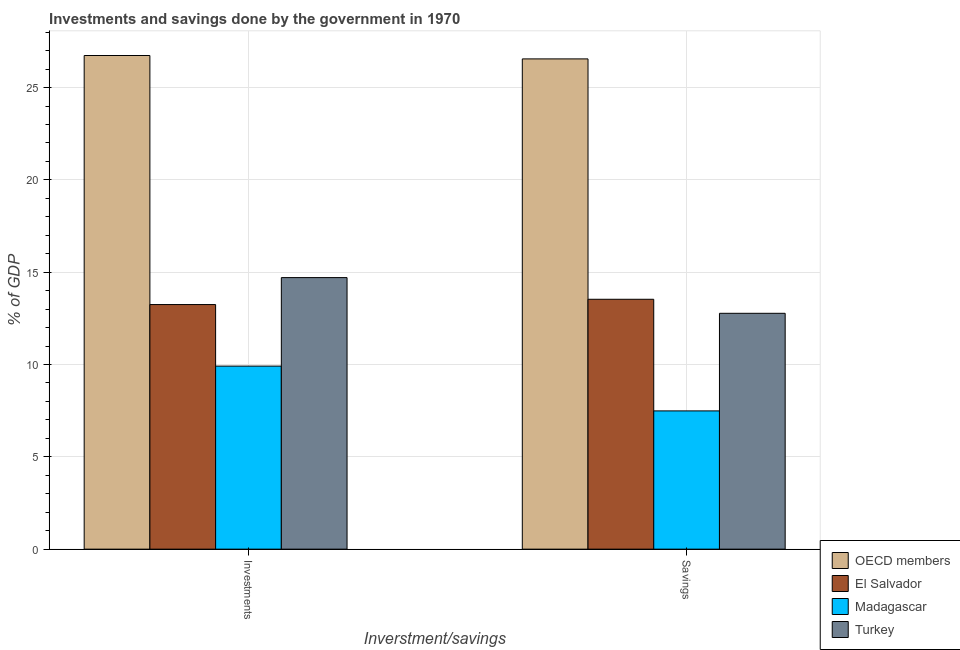Are the number of bars on each tick of the X-axis equal?
Ensure brevity in your answer.  Yes. How many bars are there on the 1st tick from the left?
Provide a succinct answer. 4. How many bars are there on the 1st tick from the right?
Make the answer very short. 4. What is the label of the 1st group of bars from the left?
Offer a very short reply. Investments. What is the savings of government in OECD members?
Ensure brevity in your answer.  26.55. Across all countries, what is the maximum savings of government?
Your answer should be compact. 26.55. Across all countries, what is the minimum investments of government?
Offer a very short reply. 9.91. In which country was the investments of government minimum?
Give a very brief answer. Madagascar. What is the total savings of government in the graph?
Offer a very short reply. 60.35. What is the difference between the savings of government in El Salvador and that in Madagascar?
Your response must be concise. 6.05. What is the difference between the savings of government in OECD members and the investments of government in Madagascar?
Your response must be concise. 16.64. What is the average investments of government per country?
Provide a short and direct response. 16.15. What is the difference between the savings of government and investments of government in Turkey?
Offer a terse response. -1.93. What is the ratio of the savings of government in El Salvador to that in OECD members?
Make the answer very short. 0.51. In how many countries, is the savings of government greater than the average savings of government taken over all countries?
Ensure brevity in your answer.  1. What does the 3rd bar from the left in Investments represents?
Make the answer very short. Madagascar. What does the 4th bar from the right in Investments represents?
Your answer should be very brief. OECD members. How many bars are there?
Offer a very short reply. 8. Are all the bars in the graph horizontal?
Make the answer very short. No. How many countries are there in the graph?
Provide a succinct answer. 4. What is the difference between two consecutive major ticks on the Y-axis?
Your response must be concise. 5. Are the values on the major ticks of Y-axis written in scientific E-notation?
Offer a very short reply. No. Does the graph contain any zero values?
Ensure brevity in your answer.  No. Does the graph contain grids?
Keep it short and to the point. Yes. Where does the legend appear in the graph?
Your answer should be very brief. Bottom right. How are the legend labels stacked?
Offer a terse response. Vertical. What is the title of the graph?
Make the answer very short. Investments and savings done by the government in 1970. What is the label or title of the X-axis?
Your response must be concise. Inverstment/savings. What is the label or title of the Y-axis?
Ensure brevity in your answer.  % of GDP. What is the % of GDP in OECD members in Investments?
Offer a terse response. 26.74. What is the % of GDP in El Salvador in Investments?
Provide a short and direct response. 13.25. What is the % of GDP of Madagascar in Investments?
Your answer should be very brief. 9.91. What is the % of GDP in Turkey in Investments?
Ensure brevity in your answer.  14.71. What is the % of GDP of OECD members in Savings?
Your answer should be very brief. 26.55. What is the % of GDP in El Salvador in Savings?
Your answer should be very brief. 13.53. What is the % of GDP of Madagascar in Savings?
Your answer should be compact. 7.49. What is the % of GDP of Turkey in Savings?
Offer a terse response. 12.77. Across all Inverstment/savings, what is the maximum % of GDP in OECD members?
Provide a succinct answer. 26.74. Across all Inverstment/savings, what is the maximum % of GDP in El Salvador?
Ensure brevity in your answer.  13.53. Across all Inverstment/savings, what is the maximum % of GDP of Madagascar?
Your response must be concise. 9.91. Across all Inverstment/savings, what is the maximum % of GDP in Turkey?
Your response must be concise. 14.71. Across all Inverstment/savings, what is the minimum % of GDP in OECD members?
Give a very brief answer. 26.55. Across all Inverstment/savings, what is the minimum % of GDP in El Salvador?
Ensure brevity in your answer.  13.25. Across all Inverstment/savings, what is the minimum % of GDP of Madagascar?
Offer a very short reply. 7.49. Across all Inverstment/savings, what is the minimum % of GDP in Turkey?
Give a very brief answer. 12.77. What is the total % of GDP in OECD members in the graph?
Keep it short and to the point. 53.29. What is the total % of GDP in El Salvador in the graph?
Make the answer very short. 26.78. What is the total % of GDP of Madagascar in the graph?
Make the answer very short. 17.4. What is the total % of GDP of Turkey in the graph?
Offer a very short reply. 27.48. What is the difference between the % of GDP of OECD members in Investments and that in Savings?
Your response must be concise. 0.18. What is the difference between the % of GDP in El Salvador in Investments and that in Savings?
Keep it short and to the point. -0.29. What is the difference between the % of GDP in Madagascar in Investments and that in Savings?
Keep it short and to the point. 2.43. What is the difference between the % of GDP of Turkey in Investments and that in Savings?
Your answer should be compact. 1.93. What is the difference between the % of GDP in OECD members in Investments and the % of GDP in El Salvador in Savings?
Provide a succinct answer. 13.2. What is the difference between the % of GDP of OECD members in Investments and the % of GDP of Madagascar in Savings?
Offer a very short reply. 19.25. What is the difference between the % of GDP in OECD members in Investments and the % of GDP in Turkey in Savings?
Your answer should be compact. 13.96. What is the difference between the % of GDP of El Salvador in Investments and the % of GDP of Madagascar in Savings?
Your answer should be very brief. 5.76. What is the difference between the % of GDP in El Salvador in Investments and the % of GDP in Turkey in Savings?
Your answer should be very brief. 0.47. What is the difference between the % of GDP of Madagascar in Investments and the % of GDP of Turkey in Savings?
Ensure brevity in your answer.  -2.86. What is the average % of GDP of OECD members per Inverstment/savings?
Offer a very short reply. 26.64. What is the average % of GDP of El Salvador per Inverstment/savings?
Give a very brief answer. 13.39. What is the average % of GDP of Madagascar per Inverstment/savings?
Ensure brevity in your answer.  8.7. What is the average % of GDP of Turkey per Inverstment/savings?
Your response must be concise. 13.74. What is the difference between the % of GDP of OECD members and % of GDP of El Salvador in Investments?
Your answer should be compact. 13.49. What is the difference between the % of GDP of OECD members and % of GDP of Madagascar in Investments?
Offer a terse response. 16.82. What is the difference between the % of GDP of OECD members and % of GDP of Turkey in Investments?
Give a very brief answer. 12.03. What is the difference between the % of GDP of El Salvador and % of GDP of Madagascar in Investments?
Offer a very short reply. 3.33. What is the difference between the % of GDP in El Salvador and % of GDP in Turkey in Investments?
Ensure brevity in your answer.  -1.46. What is the difference between the % of GDP of Madagascar and % of GDP of Turkey in Investments?
Provide a short and direct response. -4.79. What is the difference between the % of GDP in OECD members and % of GDP in El Salvador in Savings?
Your answer should be compact. 13.02. What is the difference between the % of GDP in OECD members and % of GDP in Madagascar in Savings?
Ensure brevity in your answer.  19.06. What is the difference between the % of GDP of OECD members and % of GDP of Turkey in Savings?
Offer a terse response. 13.78. What is the difference between the % of GDP in El Salvador and % of GDP in Madagascar in Savings?
Provide a succinct answer. 6.05. What is the difference between the % of GDP in El Salvador and % of GDP in Turkey in Savings?
Your answer should be very brief. 0.76. What is the difference between the % of GDP in Madagascar and % of GDP in Turkey in Savings?
Your response must be concise. -5.29. What is the ratio of the % of GDP of OECD members in Investments to that in Savings?
Your response must be concise. 1.01. What is the ratio of the % of GDP of El Salvador in Investments to that in Savings?
Your response must be concise. 0.98. What is the ratio of the % of GDP of Madagascar in Investments to that in Savings?
Keep it short and to the point. 1.32. What is the ratio of the % of GDP of Turkey in Investments to that in Savings?
Your answer should be compact. 1.15. What is the difference between the highest and the second highest % of GDP in OECD members?
Your response must be concise. 0.18. What is the difference between the highest and the second highest % of GDP in El Salvador?
Provide a succinct answer. 0.29. What is the difference between the highest and the second highest % of GDP of Madagascar?
Provide a short and direct response. 2.43. What is the difference between the highest and the second highest % of GDP of Turkey?
Keep it short and to the point. 1.93. What is the difference between the highest and the lowest % of GDP in OECD members?
Provide a succinct answer. 0.18. What is the difference between the highest and the lowest % of GDP of El Salvador?
Provide a short and direct response. 0.29. What is the difference between the highest and the lowest % of GDP of Madagascar?
Offer a terse response. 2.43. What is the difference between the highest and the lowest % of GDP in Turkey?
Provide a short and direct response. 1.93. 